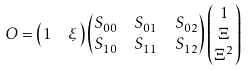<formula> <loc_0><loc_0><loc_500><loc_500>O & = \begin{pmatrix} 1 & \xi \end{pmatrix} \begin{pmatrix} S _ { 0 0 } & S _ { 0 1 } & S _ { 0 2 } \\ S _ { 1 0 } & S _ { 1 1 } & S _ { 1 2 } \end{pmatrix} \begin{pmatrix} 1 \\ \Xi \\ \Xi ^ { 2 } \end{pmatrix}</formula> 